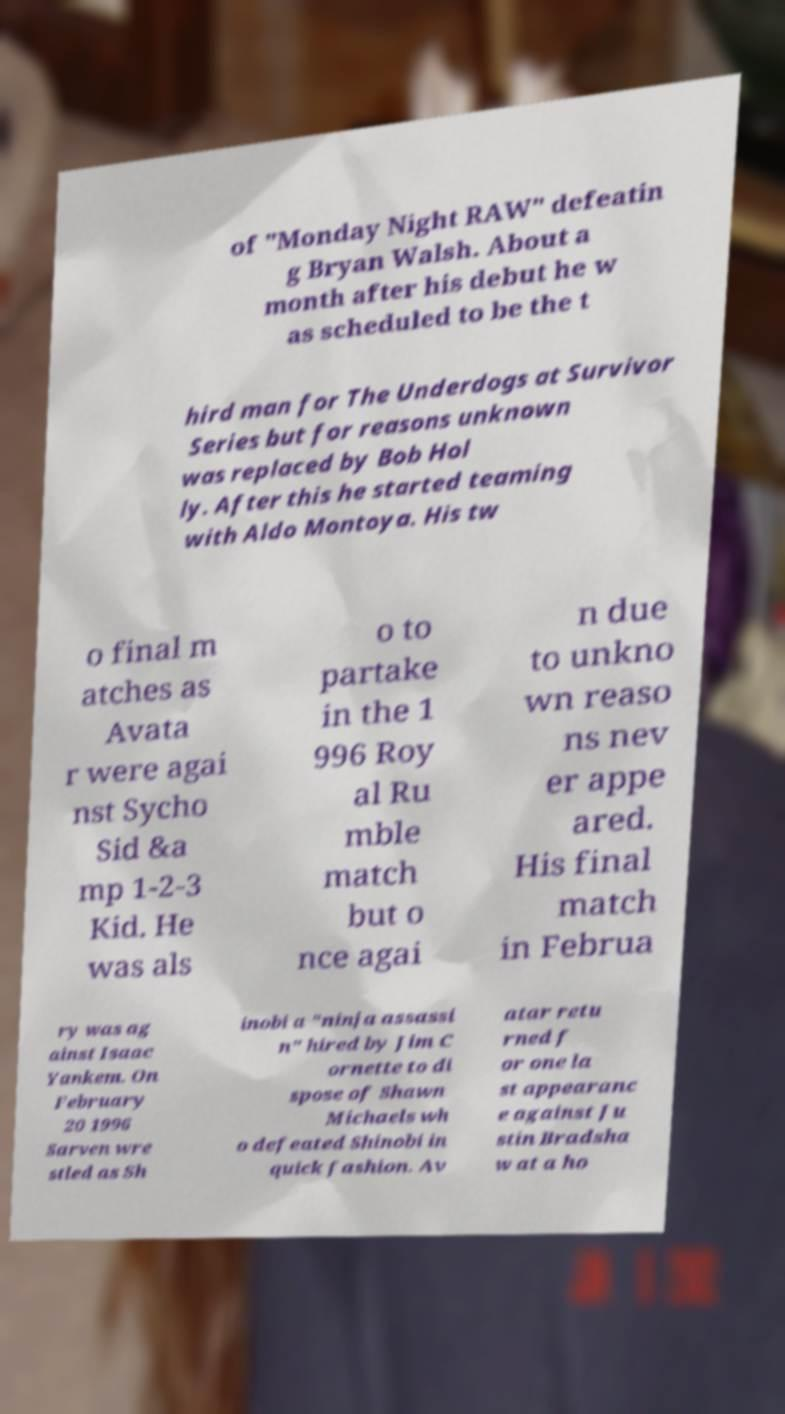What messages or text are displayed in this image? I need them in a readable, typed format. of "Monday Night RAW" defeatin g Bryan Walsh. About a month after his debut he w as scheduled to be the t hird man for The Underdogs at Survivor Series but for reasons unknown was replaced by Bob Hol ly. After this he started teaming with Aldo Montoya. His tw o final m atches as Avata r were agai nst Sycho Sid &a mp 1-2-3 Kid. He was als o to partake in the 1 996 Roy al Ru mble match but o nce agai n due to unkno wn reaso ns nev er appe ared. His final match in Februa ry was ag ainst Isaac Yankem. On February 20 1996 Sarven wre stled as Sh inobi a "ninja assassi n" hired by Jim C ornette to di spose of Shawn Michaels wh o defeated Shinobi in quick fashion. Av atar retu rned f or one la st appearanc e against Ju stin Bradsha w at a ho 